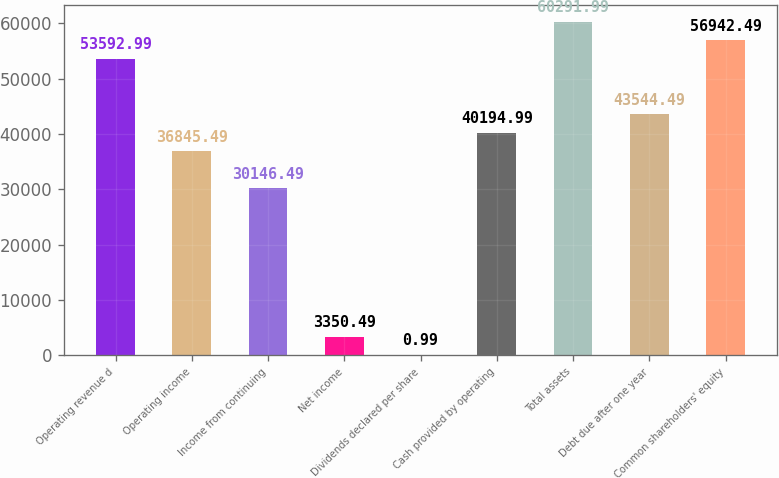Convert chart. <chart><loc_0><loc_0><loc_500><loc_500><bar_chart><fcel>Operating revenue d<fcel>Operating income<fcel>Income from continuing<fcel>Net income<fcel>Dividends declared per share<fcel>Cash provided by operating<fcel>Total assets<fcel>Debt due after one year<fcel>Common shareholders' equity<nl><fcel>53593<fcel>36845.5<fcel>30146.5<fcel>3350.49<fcel>0.99<fcel>40195<fcel>60292<fcel>43544.5<fcel>56942.5<nl></chart> 